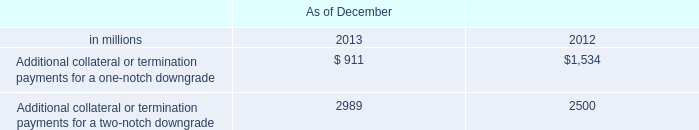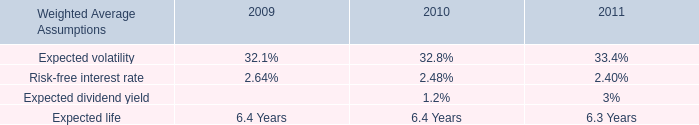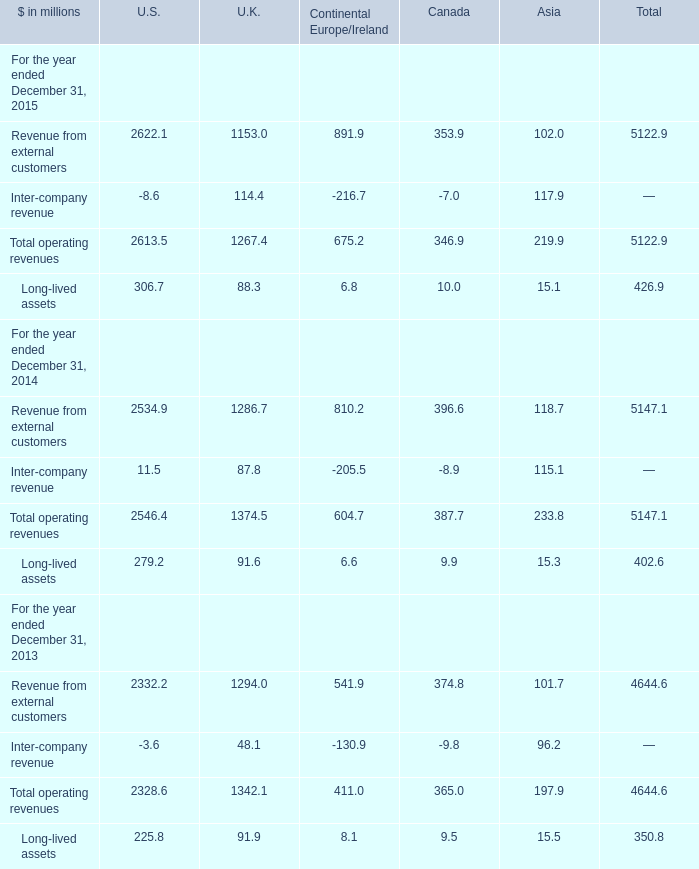When does Total operating revenues in terms of U.S. reach the largest value? 
Answer: 2015. 